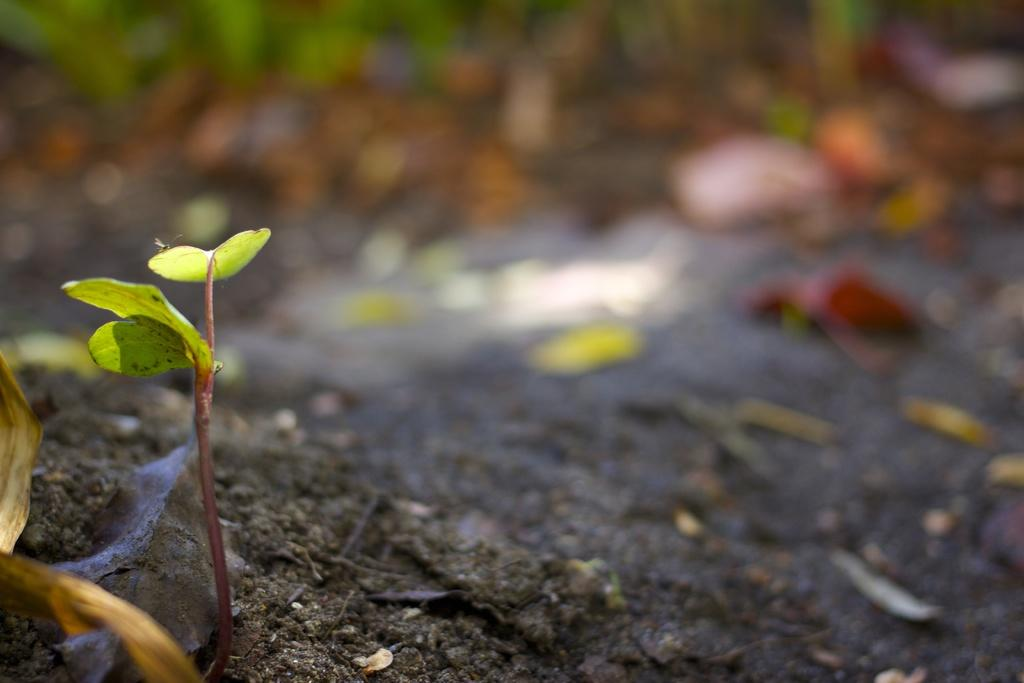What is located on the left side of the image? There is a seedling on the left side of the image. What can be found at the bottom of the image? There is soil at the bottom of the image. What type of plant material is visible in the image? Leaves are visible in the image. Where is the beggar standing in the image? There is no beggar present in the image. What type of trail can be seen in the image? There is no trail visible in the image. 